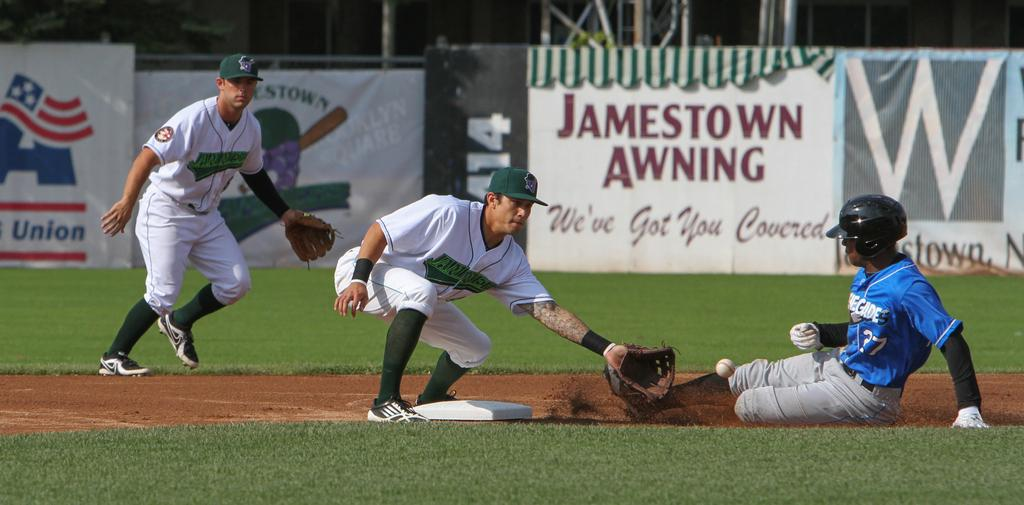<image>
Relay a brief, clear account of the picture shown. A baseball player tries to tag someone out, in front of a sign for Jamestown Awning. 